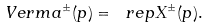<formula> <loc_0><loc_0><loc_500><loc_500>\ V e r m a ^ { \pm } ( p ) = \ r e p X ^ { \pm } ( p ) .</formula> 